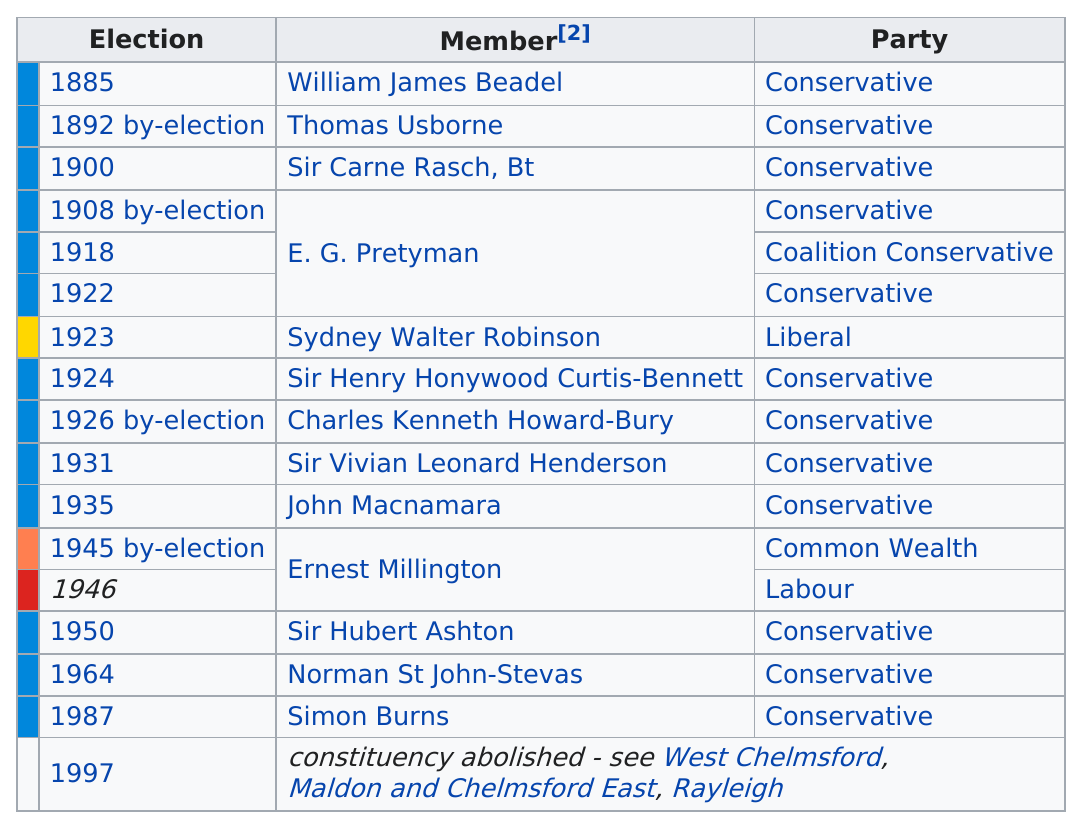Draw attention to some important aspects in this diagram. Out of the 1 member who identified with the Liberal Party, 1 member indicated a preference for that party. After Sir Carne Rasch's election, John Macnamara was elected 35 years later. 